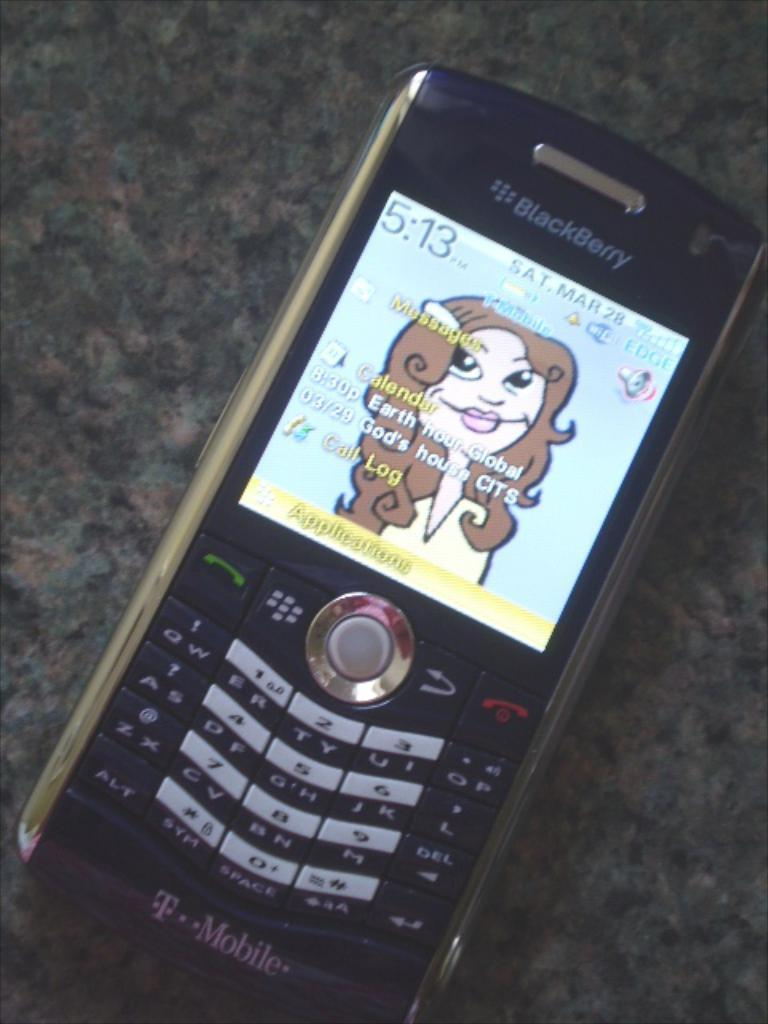<image>
Describe the image concisely. A simple black BlackBerry with a woman as its background. 